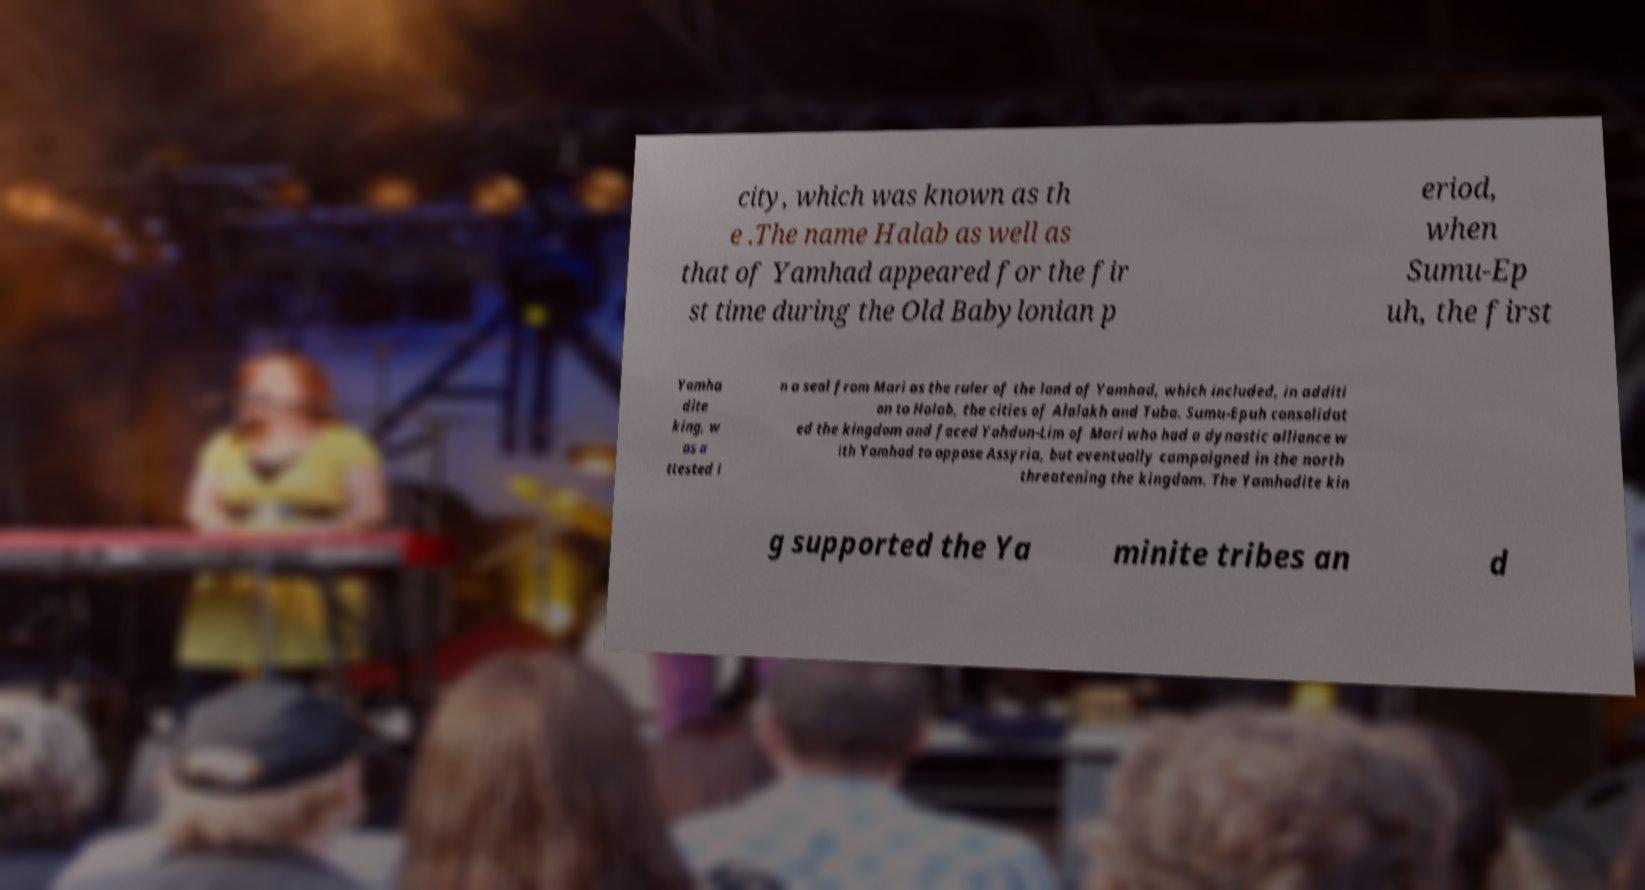Could you extract and type out the text from this image? city, which was known as th e .The name Halab as well as that of Yamhad appeared for the fir st time during the Old Babylonian p eriod, when Sumu-Ep uh, the first Yamha dite king, w as a ttested i n a seal from Mari as the ruler of the land of Yamhad, which included, in additi on to Halab, the cities of Alalakh and Tuba. Sumu-Epuh consolidat ed the kingdom and faced Yahdun-Lim of Mari who had a dynastic alliance w ith Yamhad to oppose Assyria, but eventually campaigned in the north threatening the kingdom. The Yamhadite kin g supported the Ya minite tribes an d 